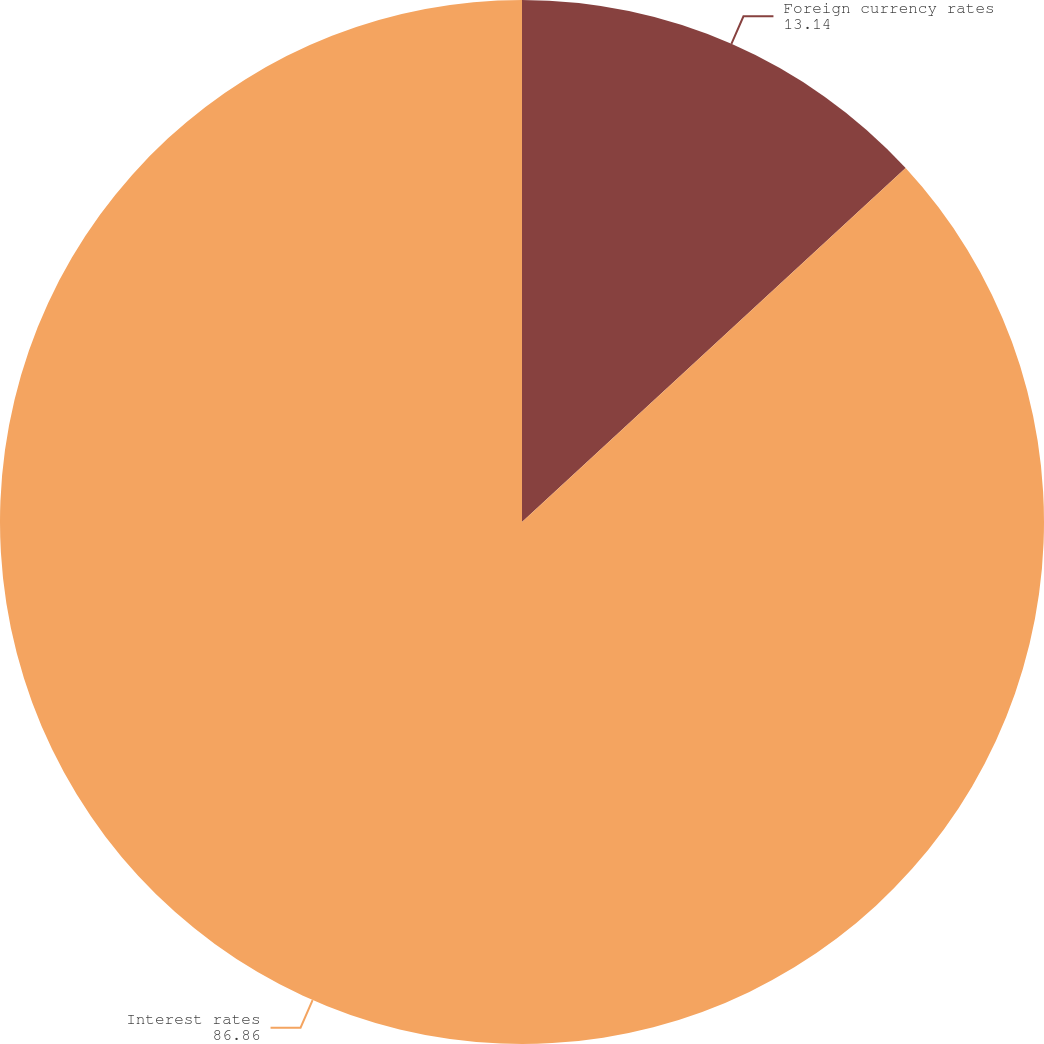Convert chart. <chart><loc_0><loc_0><loc_500><loc_500><pie_chart><fcel>Foreign currency rates<fcel>Interest rates<nl><fcel>13.14%<fcel>86.86%<nl></chart> 